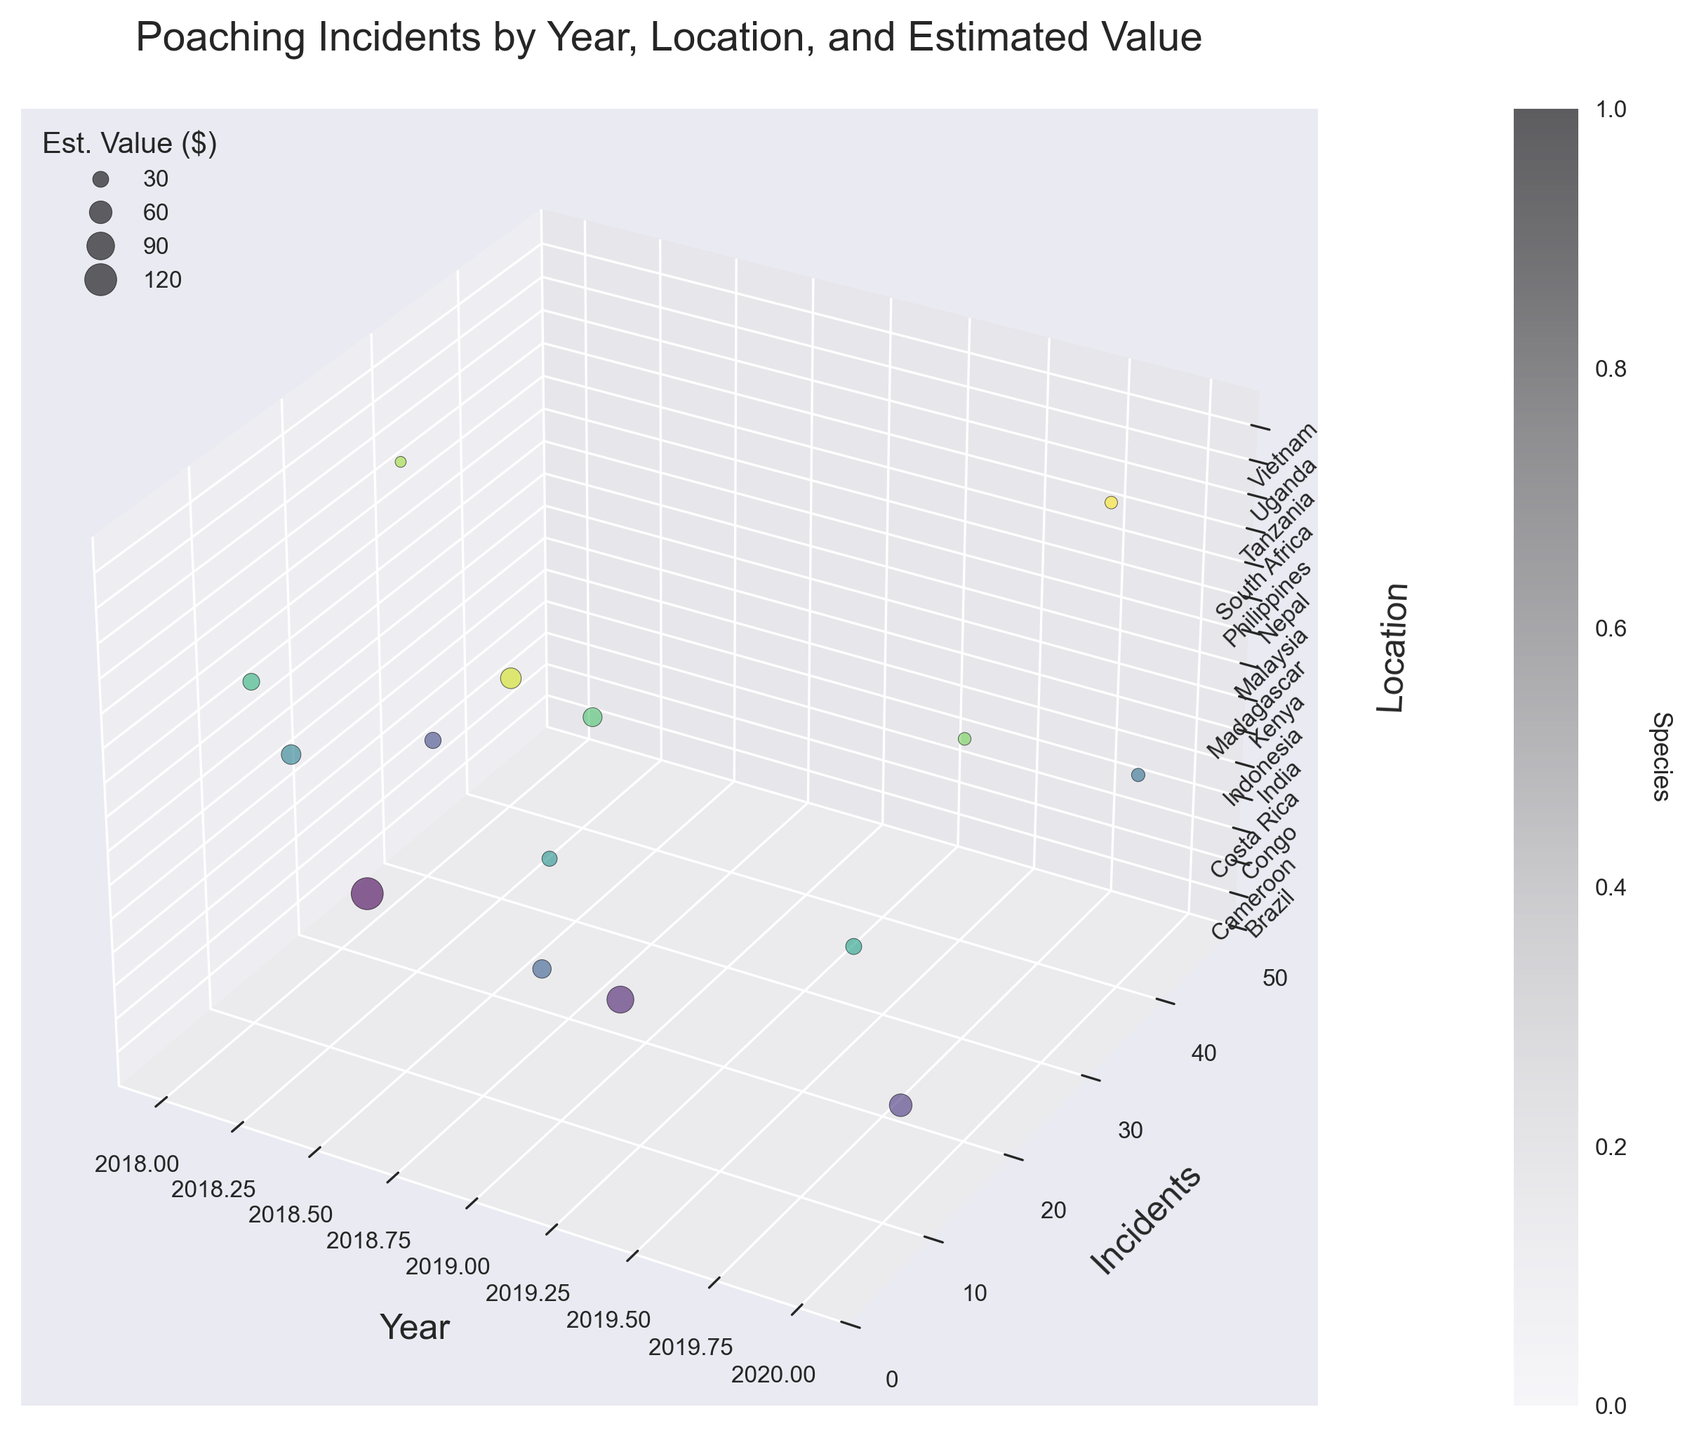How is the title of the plot labeled? The plot title is prominently displayed at the top of the figure, indicating the subject and scope of the data being shown, "Poaching Incidents by Year, Location, and Estimated Value." This can be read directly within the figure.
Answer: Poaching Incidents by Year, Location, and Estimated Value How many locations are represented in the data? To determine the number of locations, you can count the distinct labels on the Z-axis or refer to the Z-axis tick labels since each unique location is distinctly shown here.
Answer: 15 Which year had the most poaching incidents reported? By examining the X-axis (Year) and looking for the highest Y-axis (Incidents) value, we can identify the year with the most incidents, in this case, 2020, where one bubble reaches a high number of incidents.
Answer: 2020 Which species had the highest estimated black market value in 2019? Locate the bubbles for 2019 on the X-axis and check the size to identify the largest bubble value (Y-axis). The species with the largest bubble in 2019 is the Rhino in South Africa, indicating the highest black market value.
Answer: Rhino What is the trend in poaching incidents over the three years? Compare the position of bubbles across the three years on the X-axis. This reveals that incidents had varied considerable with no consistent upward or downward trend. Notably, 2020 sees some high outliers, such as Sea Turtles in Costa Rica.
Answer: Varied Between African Elephants in Kenya and Tigers in India, which had a higher estimated black market value? By finding the corresponding bubbles for African Elephants (Kenya, 2018) and Tigers (India, 2020) and comparing their sizes, the African Elephants have a larger bubble, indicating a higher value.
Answer: African Elephants Which species appears to be the most frequently poached based on incident numbers? Scanning across the Y-axis for different species and noting the highest position strengthens this, notably Sea Turtle in Costa Rica in 2020 with a large incident number.
Answer: Sea Turtle Which location had the highest black market value poaching incident(s) in 2018? By identifying the largest bubble size in the Z-axis among the 2018 data points, Kenya emerges as having the highest value due to the African Elephant incidents.
Answer: Kenya 